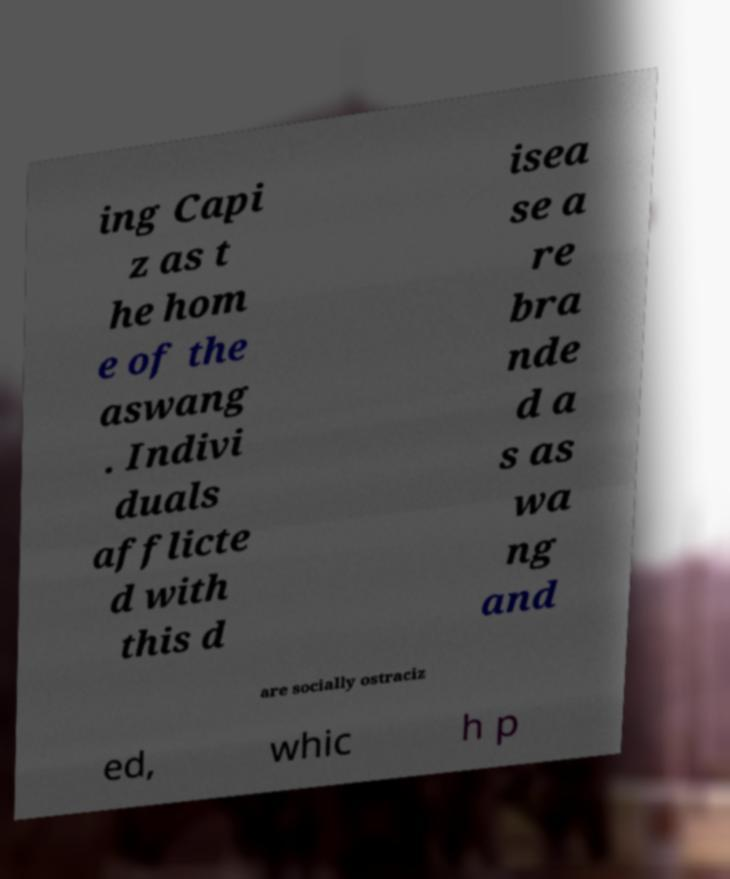Could you extract and type out the text from this image? ing Capi z as t he hom e of the aswang . Indivi duals afflicte d with this d isea se a re bra nde d a s as wa ng and are socially ostraciz ed, whic h p 